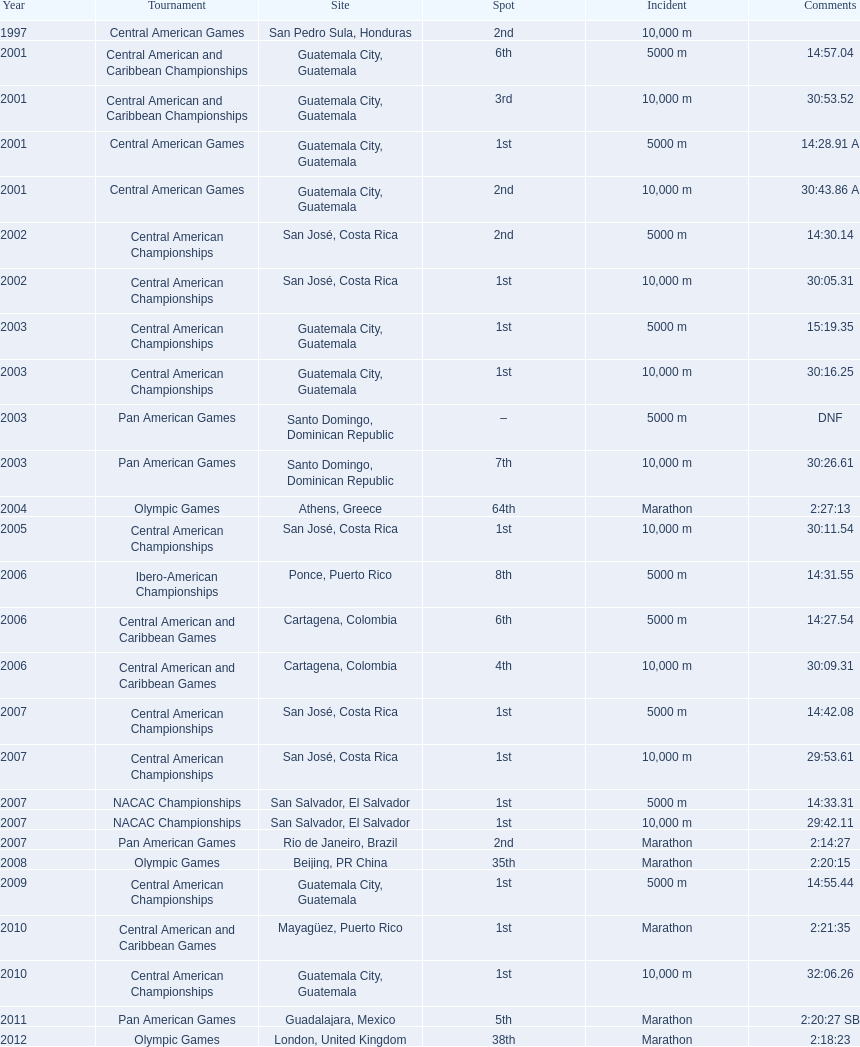How many times has this athlete not finished in a competition? 1. 